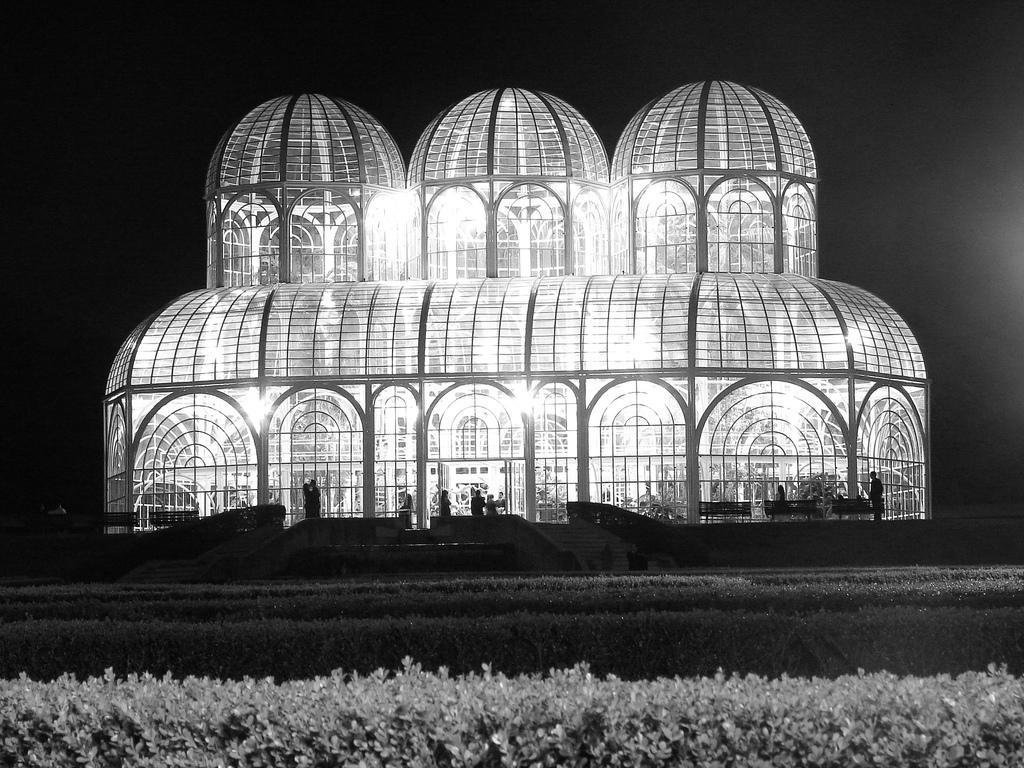Could you give a brief overview of what you see in this image? In this picture we can see plants, building, people and in the background we can see it is dark. 